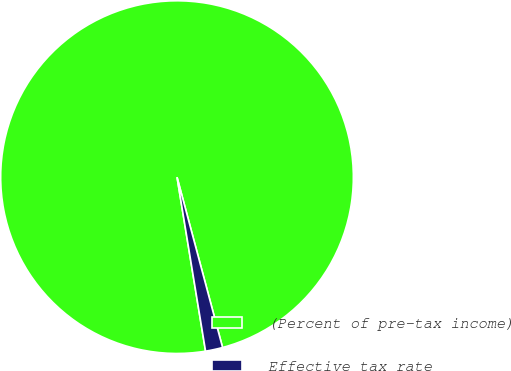Convert chart to OTSL. <chart><loc_0><loc_0><loc_500><loc_500><pie_chart><fcel>(Percent of pre-tax income)<fcel>Effective tax rate<nl><fcel>98.43%<fcel>1.57%<nl></chart> 